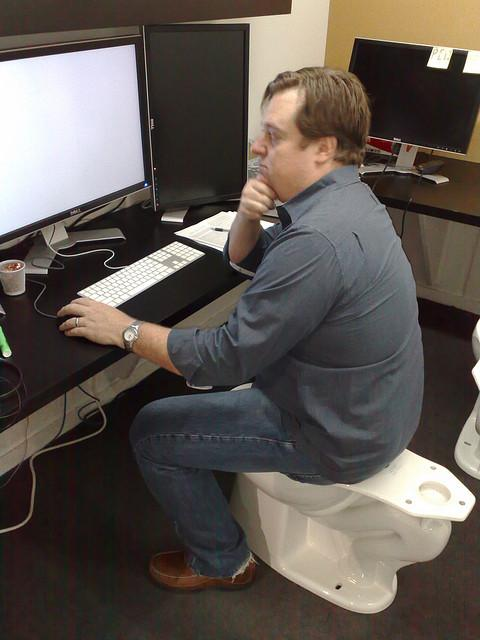What part of this mans furniture is most surprising?

Choices:
A) desk
B) toilet
C) speaker
D) flooring holder toilet 